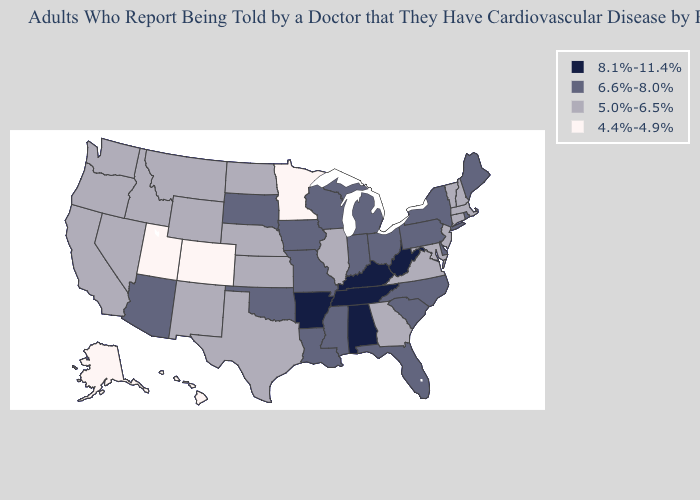Does North Dakota have the lowest value in the USA?
Be succinct. No. Does Connecticut have the lowest value in the Northeast?
Give a very brief answer. Yes. What is the lowest value in the USA?
Keep it brief. 4.4%-4.9%. Name the states that have a value in the range 6.6%-8.0%?
Short answer required. Arizona, Delaware, Florida, Indiana, Iowa, Louisiana, Maine, Michigan, Mississippi, Missouri, New York, North Carolina, Ohio, Oklahoma, Pennsylvania, Rhode Island, South Carolina, South Dakota, Wisconsin. Which states have the lowest value in the West?
Concise answer only. Alaska, Colorado, Hawaii, Utah. Among the states that border Montana , does North Dakota have the lowest value?
Give a very brief answer. Yes. What is the value of Minnesota?
Be succinct. 4.4%-4.9%. What is the lowest value in the Northeast?
Write a very short answer. 5.0%-6.5%. What is the value of Kentucky?
Keep it brief. 8.1%-11.4%. Which states have the lowest value in the USA?
Concise answer only. Alaska, Colorado, Hawaii, Minnesota, Utah. What is the value of South Dakota?
Concise answer only. 6.6%-8.0%. Does Alabama have the lowest value in the South?
Concise answer only. No. What is the lowest value in states that border Pennsylvania?
Give a very brief answer. 5.0%-6.5%. Does Massachusetts have the lowest value in the Northeast?
Give a very brief answer. Yes. Among the states that border North Dakota , which have the lowest value?
Be succinct. Minnesota. 